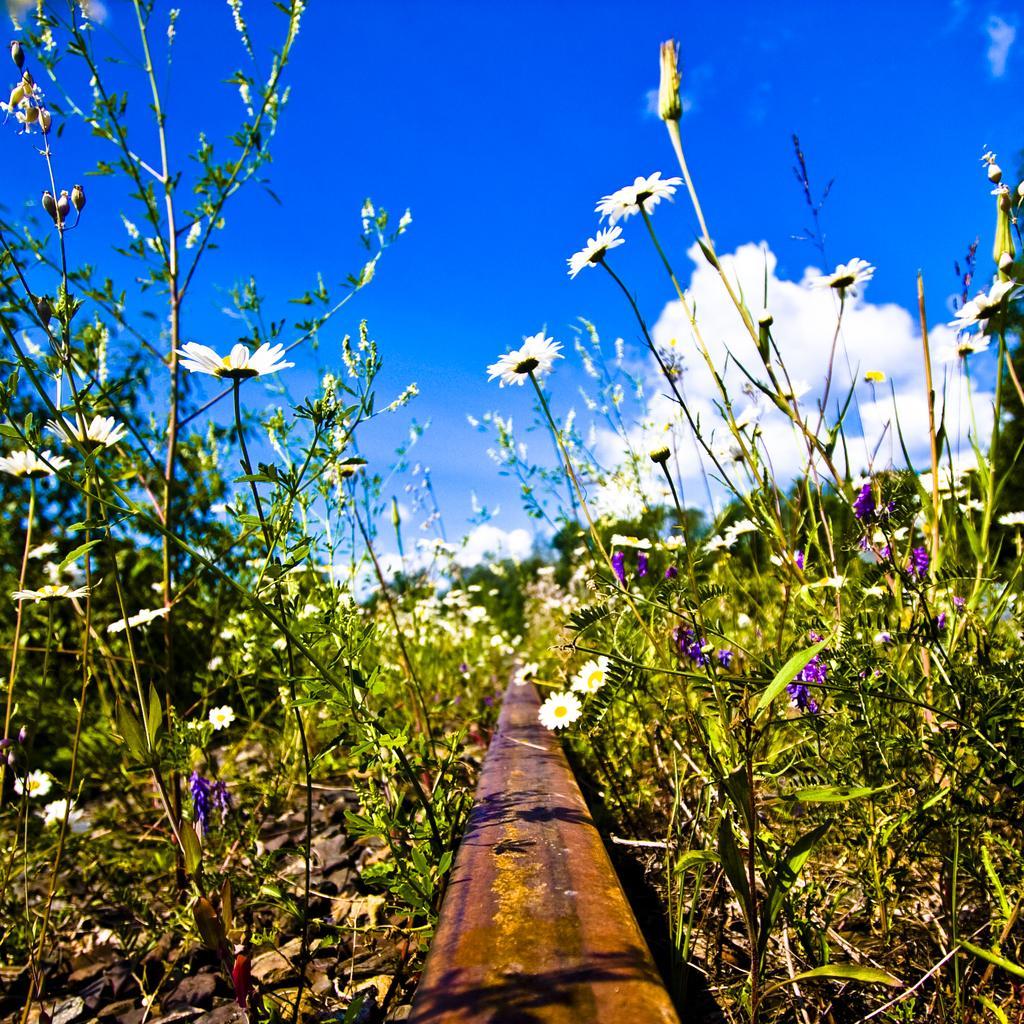In one or two sentences, can you explain what this image depicts? In the image I can see some plants to which there are some flowers and also I can see the cloudy sky. 